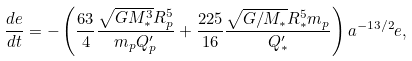Convert formula to latex. <formula><loc_0><loc_0><loc_500><loc_500>\frac { d e } { d t } = - \left ( \frac { 6 3 } { 4 } \frac { \sqrt { G M _ { * } ^ { 3 } } R _ { p } ^ { 5 } } { m _ { p } Q ^ { \prime } _ { p } } + \frac { 2 2 5 } { 1 6 } \frac { \sqrt { G / M _ { * } } R _ { * } ^ { 5 } m _ { p } } { Q ^ { \prime } _ { * } } \right ) a ^ { - 1 3 / 2 } e ,</formula> 